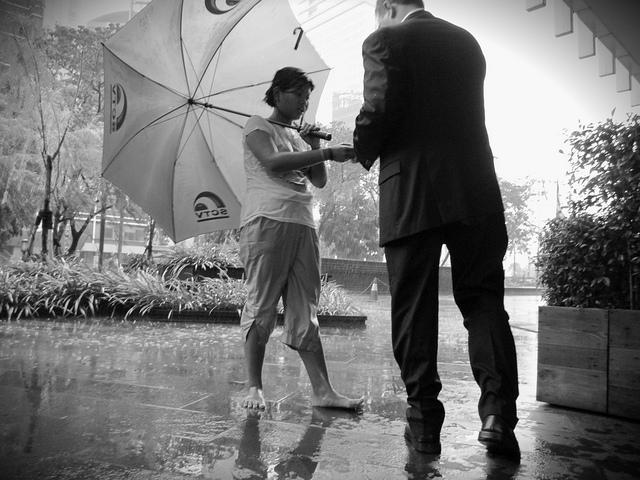What is the man wearing?
Answer briefly. Suit. How many umbrellas are there?
Answer briefly. 1. Is the photo colored?
Short answer required. No. Will the woman's feet be wet?
Short answer required. Yes. 